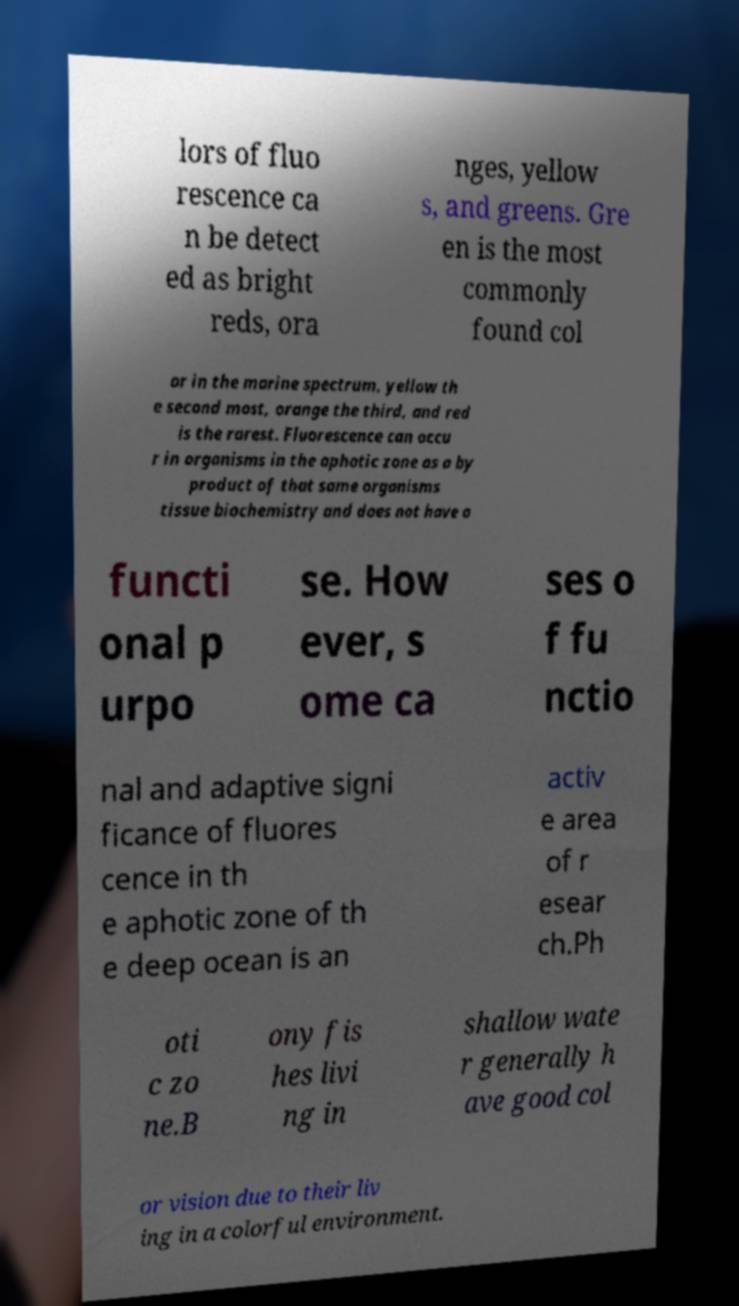What messages or text are displayed in this image? I need them in a readable, typed format. lors of fluo rescence ca n be detect ed as bright reds, ora nges, yellow s, and greens. Gre en is the most commonly found col or in the marine spectrum, yellow th e second most, orange the third, and red is the rarest. Fluorescence can occu r in organisms in the aphotic zone as a by product of that same organisms tissue biochemistry and does not have a functi onal p urpo se. How ever, s ome ca ses o f fu nctio nal and adaptive signi ficance of fluores cence in th e aphotic zone of th e deep ocean is an activ e area of r esear ch.Ph oti c zo ne.B ony fis hes livi ng in shallow wate r generally h ave good col or vision due to their liv ing in a colorful environment. 